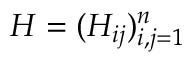<formula> <loc_0><loc_0><loc_500><loc_500>H = ( H _ { i j } ) _ { i , j = 1 } ^ { n }</formula> 